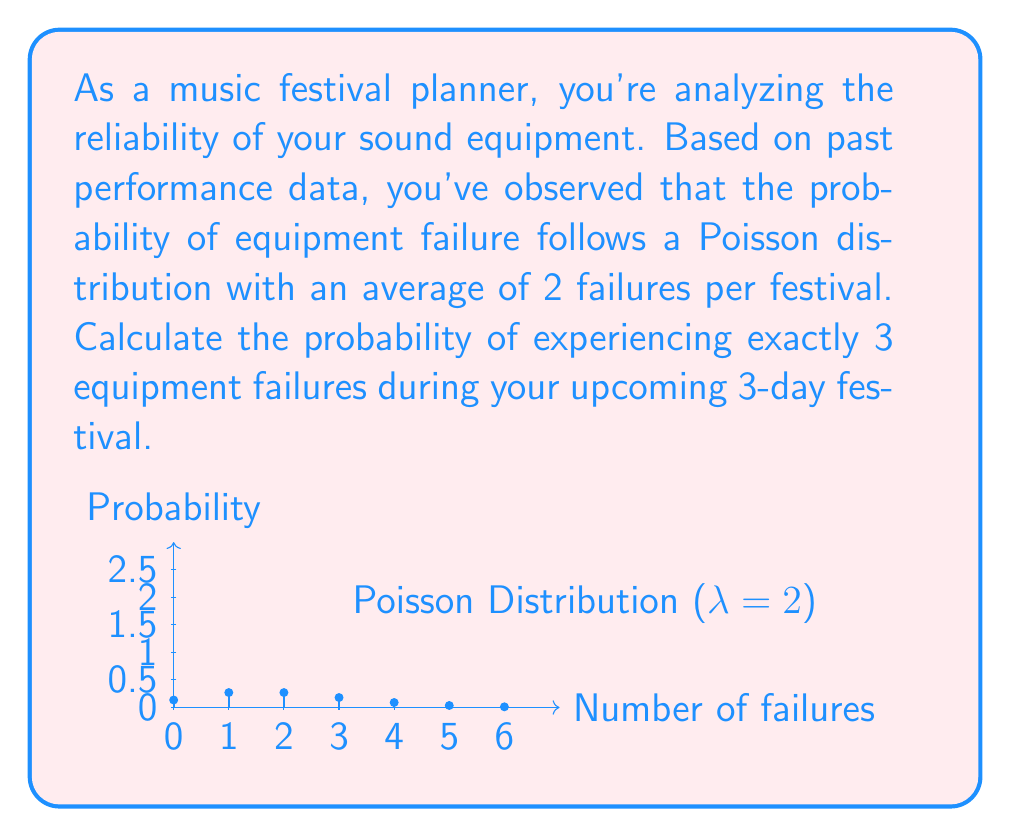Teach me how to tackle this problem. To solve this problem, we'll use the Poisson probability mass function:

$$P(X = k) = \frac{e^{-\lambda} \lambda^k}{k!}$$

Where:
$\lambda$ = average number of events (failures) in the given time period
$k$ = number of events we're calculating the probability for
$e$ = Euler's number (approximately 2.71828)

Given:
$\lambda = 2$ (average of 2 failures per festival)
$k = 3$ (we're calculating the probability of exactly 3 failures)

Step 1: Substitute the values into the formula:

$$P(X = 3) = \frac{e^{-2} 2^3}{3!}$$

Step 2: Calculate $2^3$:
$$P(X = 3) = \frac{e^{-2} 8}{3!}$$

Step 3: Calculate 3! (3 factorial):
$$P(X = 3) = \frac{e^{-2} 8}{6}$$

Step 4: Simplify:
$$P(X = 3) = \frac{4e^{-2}}{3}$$

Step 5: Calculate $e^{-2}$ (you can use a calculator for this):
$$P(X = 3) = \frac{4 * 0.1353}{3} \approx 0.1804$$

Therefore, the probability of experiencing exactly 3 equipment failures during the upcoming 3-day festival is approximately 0.1804 or 18.04%.
Answer: 0.1804 (or 18.04%) 